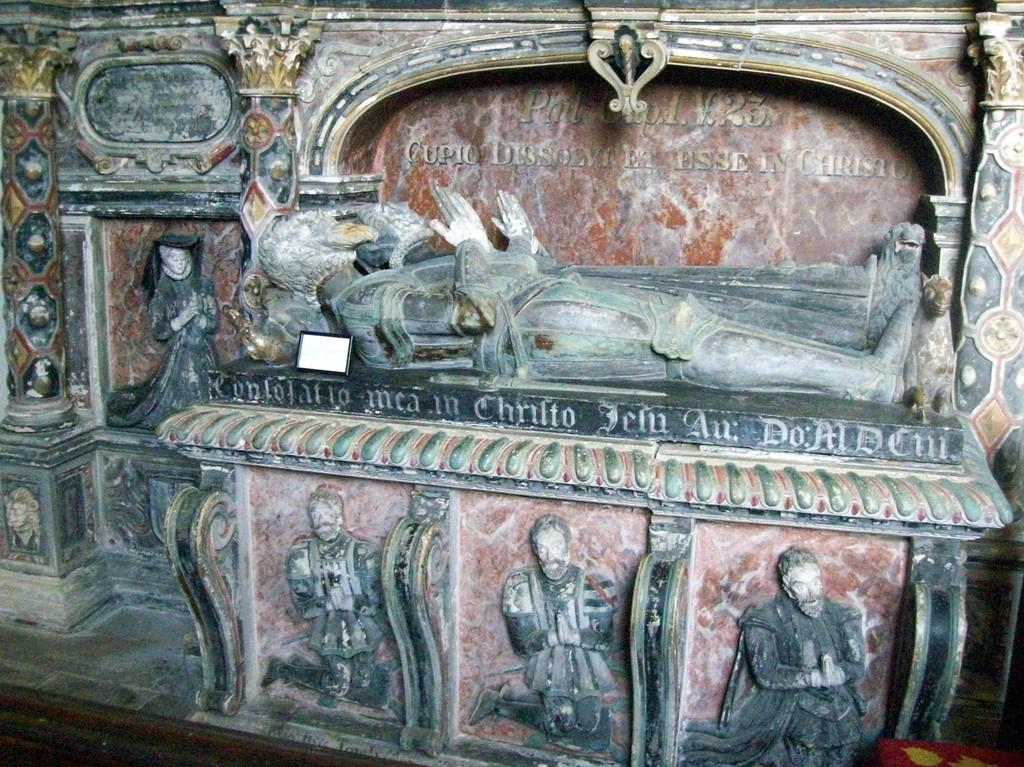What type of objects are depicted in the image? There are sculptures of persons in the image. Can you describe any additional elements in the image? Yes, there is some text in the image. How fast are the sculptures running in the image? The sculptures are not running in the image, as they are stationary objects. 